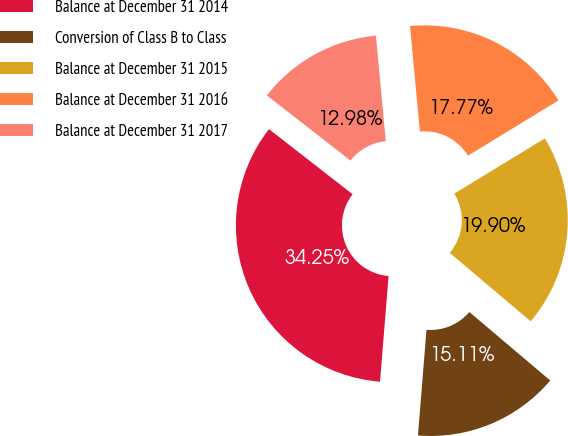<chart> <loc_0><loc_0><loc_500><loc_500><pie_chart><fcel>Balance at December 31 2014<fcel>Conversion of Class B to Class<fcel>Balance at December 31 2015<fcel>Balance at December 31 2016<fcel>Balance at December 31 2017<nl><fcel>34.25%<fcel>15.11%<fcel>19.9%<fcel>17.77%<fcel>12.98%<nl></chart> 